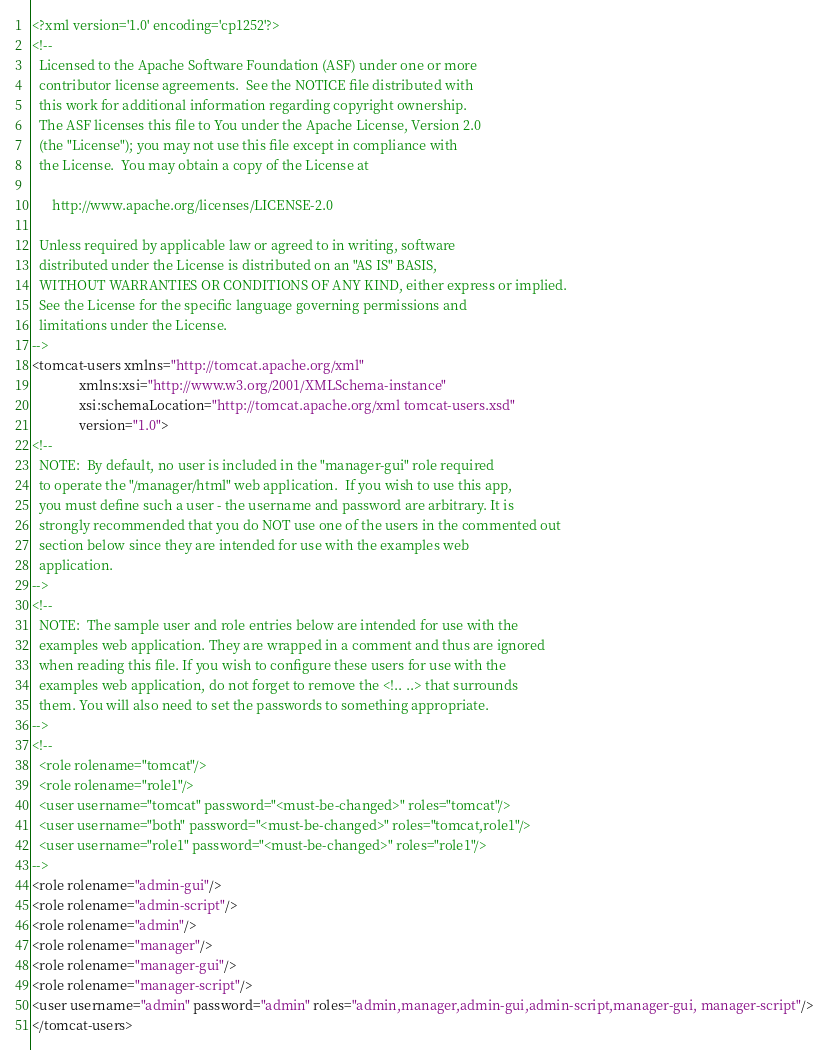<code> <loc_0><loc_0><loc_500><loc_500><_XML_><?xml version='1.0' encoding='cp1252'?>
<!--
  Licensed to the Apache Software Foundation (ASF) under one or more
  contributor license agreements.  See the NOTICE file distributed with
  this work for additional information regarding copyright ownership.
  The ASF licenses this file to You under the Apache License, Version 2.0
  (the "License"); you may not use this file except in compliance with
  the License.  You may obtain a copy of the License at

      http://www.apache.org/licenses/LICENSE-2.0

  Unless required by applicable law or agreed to in writing, software
  distributed under the License is distributed on an "AS IS" BASIS,
  WITHOUT WARRANTIES OR CONDITIONS OF ANY KIND, either express or implied.
  See the License for the specific language governing permissions and
  limitations under the License.
-->
<tomcat-users xmlns="http://tomcat.apache.org/xml"
              xmlns:xsi="http://www.w3.org/2001/XMLSchema-instance"
              xsi:schemaLocation="http://tomcat.apache.org/xml tomcat-users.xsd"
              version="1.0">
<!--
  NOTE:  By default, no user is included in the "manager-gui" role required
  to operate the "/manager/html" web application.  If you wish to use this app,
  you must define such a user - the username and password are arbitrary. It is
  strongly recommended that you do NOT use one of the users in the commented out
  section below since they are intended for use with the examples web
  application.
-->
<!--
  NOTE:  The sample user and role entries below are intended for use with the
  examples web application. They are wrapped in a comment and thus are ignored
  when reading this file. If you wish to configure these users for use with the
  examples web application, do not forget to remove the <!.. ..> that surrounds
  them. You will also need to set the passwords to something appropriate.
-->
<!--
  <role rolename="tomcat"/>
  <role rolename="role1"/>
  <user username="tomcat" password="<must-be-changed>" roles="tomcat"/>
  <user username="both" password="<must-be-changed>" roles="tomcat,role1"/>
  <user username="role1" password="<must-be-changed>" roles="role1"/>
-->
<role rolename="admin-gui"/>
<role rolename="admin-script"/>
<role rolename="admin"/>
<role rolename="manager"/>
<role rolename="manager-gui"/>
<role rolename="manager-script"/>
<user username="admin" password="admin" roles="admin,manager,admin-gui,admin-script,manager-gui, manager-script"/>
</tomcat-users>
</code> 